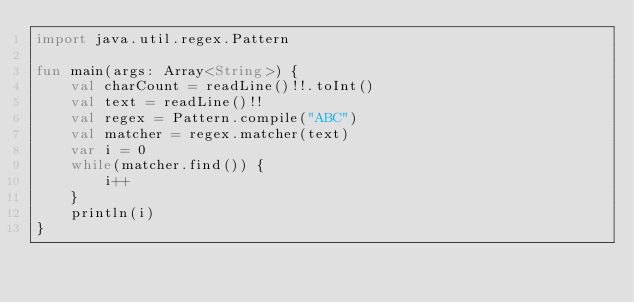Convert code to text. <code><loc_0><loc_0><loc_500><loc_500><_Kotlin_>import java.util.regex.Pattern

fun main(args: Array<String>) {
    val charCount = readLine()!!.toInt()
    val text = readLine()!!
    val regex = Pattern.compile("ABC")
    val matcher = regex.matcher(text)
    var i = 0
    while(matcher.find()) {
        i++
    }
    println(i)
}</code> 